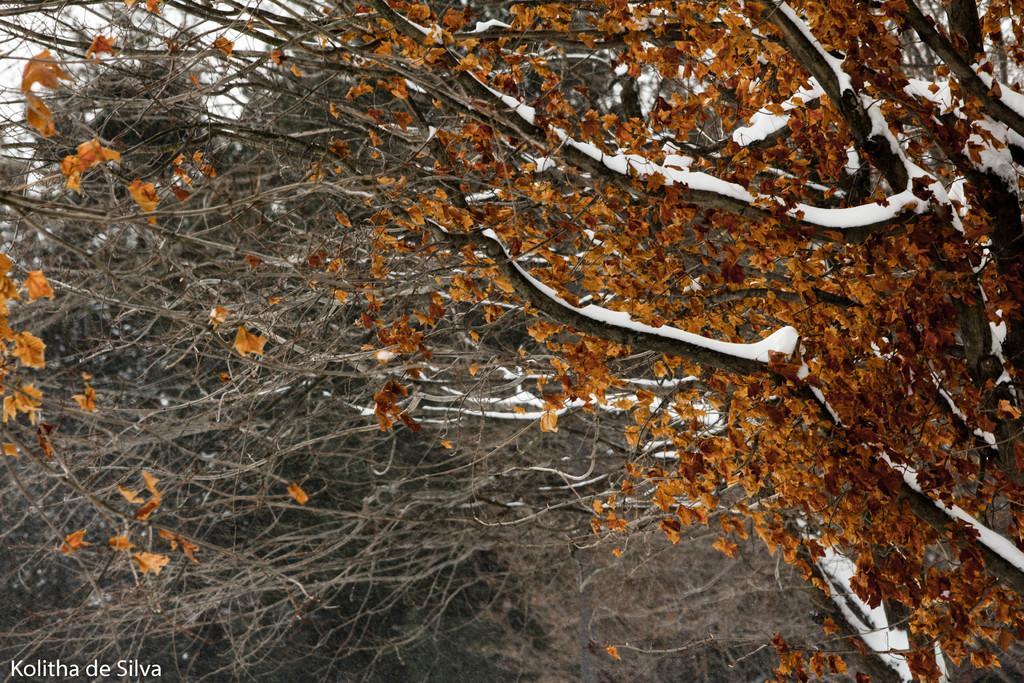Can you describe this image briefly? In this image we can see a group of trees, some trees are covered with snow. At the top of the image we can see the sky. 